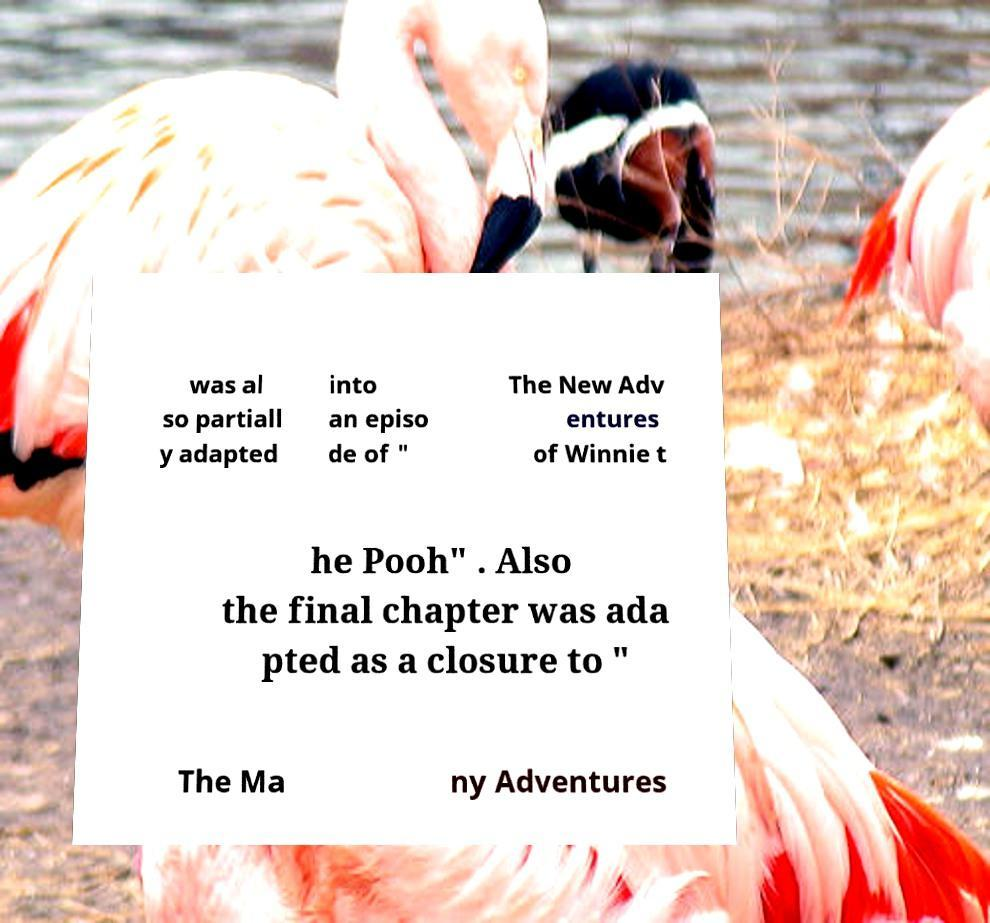There's text embedded in this image that I need extracted. Can you transcribe it verbatim? was al so partiall y adapted into an episo de of " The New Adv entures of Winnie t he Pooh" . Also the final chapter was ada pted as a closure to " The Ma ny Adventures 